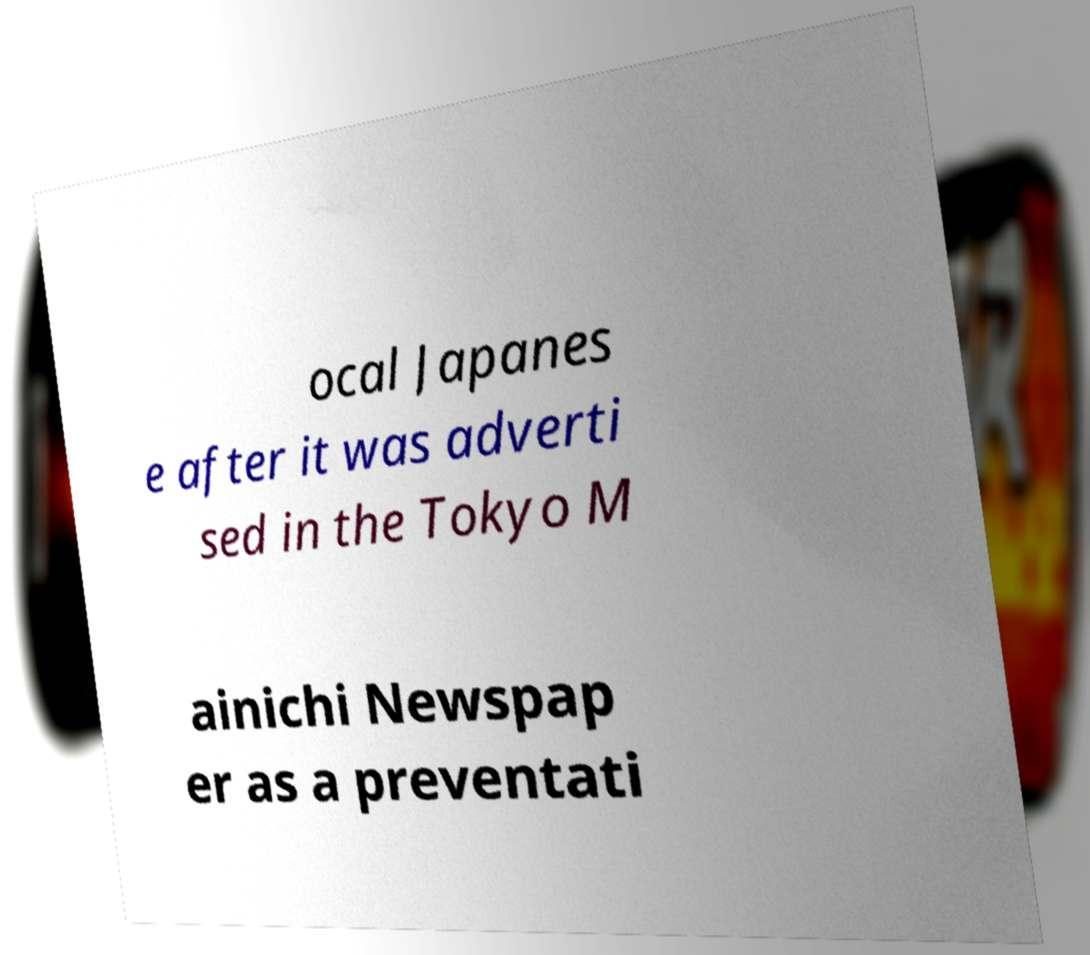Can you read and provide the text displayed in the image?This photo seems to have some interesting text. Can you extract and type it out for me? ocal Japanes e after it was adverti sed in the Tokyo M ainichi Newspap er as a preventati 